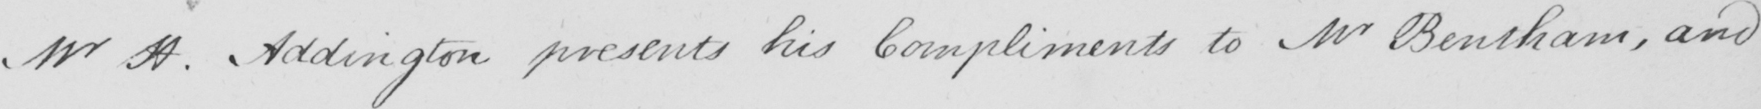Can you read and transcribe this handwriting? Mr H . Addington presents his Compliments to Mr Bentham , and 